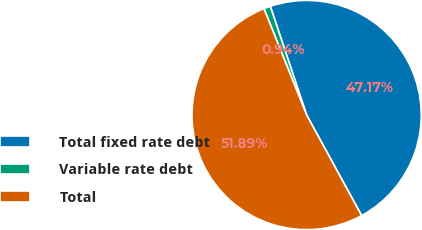Convert chart. <chart><loc_0><loc_0><loc_500><loc_500><pie_chart><fcel>Total fixed rate debt<fcel>Variable rate debt<fcel>Total<nl><fcel>47.17%<fcel>0.94%<fcel>51.89%<nl></chart> 